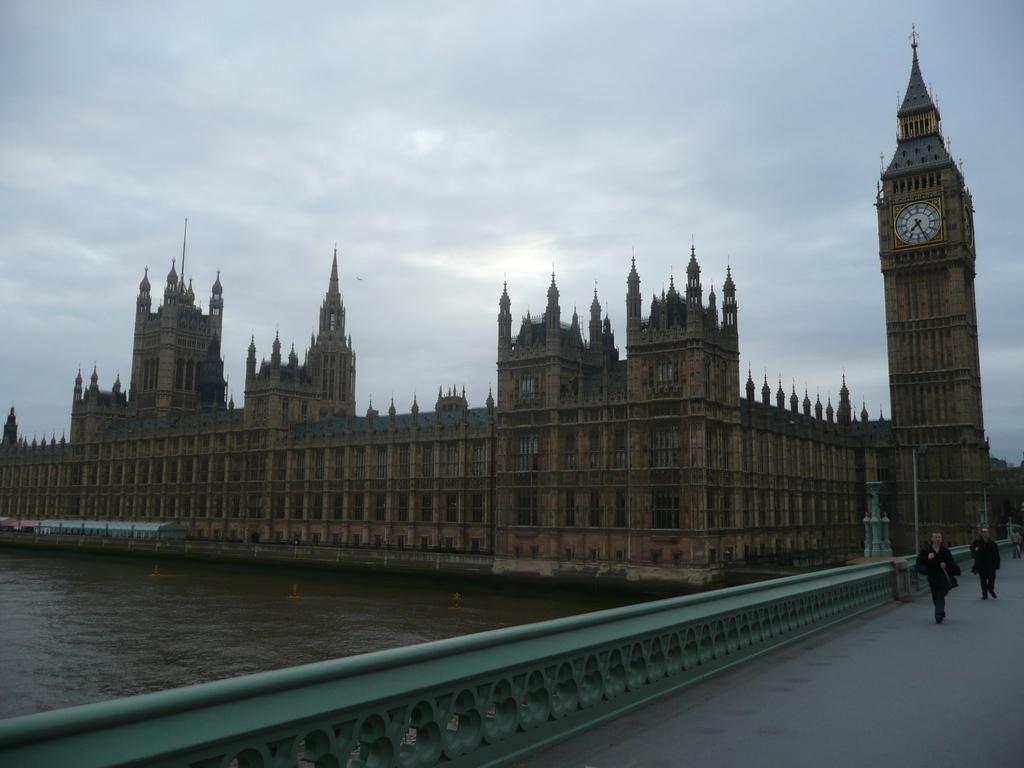Can you describe this image briefly? On the left side there is water, on the right side it is the bridge. Few people are working on it, in the middle it is a very big building. On the right side there is a clock in the tower. 